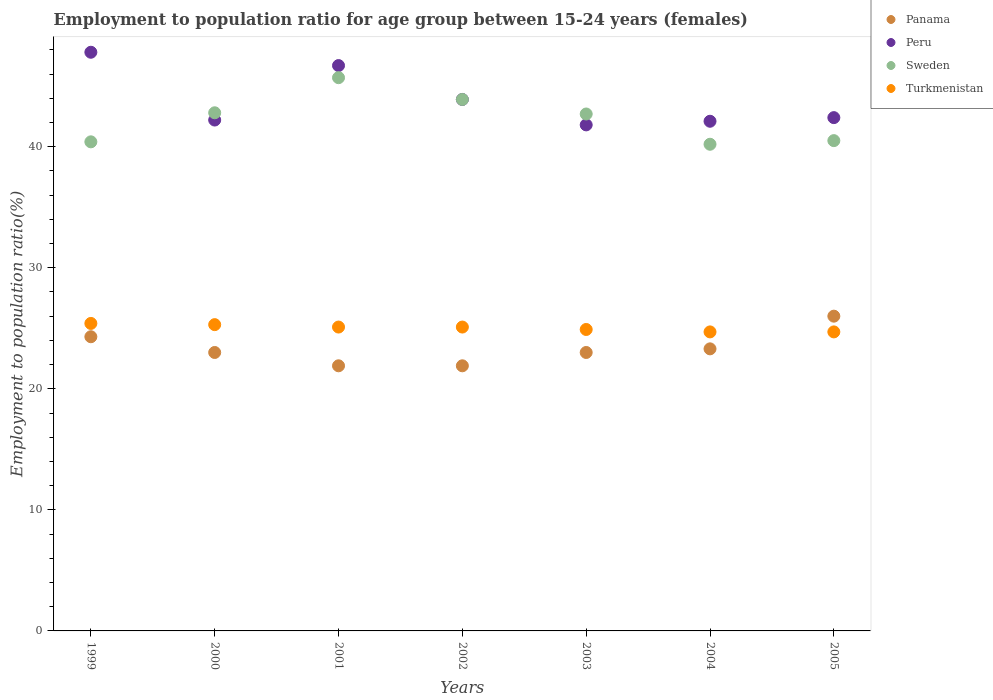What is the employment to population ratio in Peru in 2000?
Give a very brief answer. 42.2. Across all years, what is the maximum employment to population ratio in Turkmenistan?
Provide a succinct answer. 25.4. Across all years, what is the minimum employment to population ratio in Turkmenistan?
Your response must be concise. 24.7. In which year was the employment to population ratio in Turkmenistan minimum?
Offer a terse response. 2004. What is the total employment to population ratio in Peru in the graph?
Your answer should be very brief. 306.9. What is the difference between the employment to population ratio in Turkmenistan in 2001 and that in 2003?
Provide a short and direct response. 0.2. What is the difference between the employment to population ratio in Panama in 2000 and the employment to population ratio in Sweden in 2005?
Make the answer very short. -17.5. What is the average employment to population ratio in Turkmenistan per year?
Offer a very short reply. 25.03. In the year 2000, what is the difference between the employment to population ratio in Peru and employment to population ratio in Panama?
Offer a very short reply. 19.2. What is the ratio of the employment to population ratio in Sweden in 2003 to that in 2005?
Ensure brevity in your answer.  1.05. What is the difference between the highest and the second highest employment to population ratio in Panama?
Your answer should be very brief. 1.7. What is the difference between the highest and the lowest employment to population ratio in Panama?
Keep it short and to the point. 4.1. In how many years, is the employment to population ratio in Sweden greater than the average employment to population ratio in Sweden taken over all years?
Offer a very short reply. 4. Is it the case that in every year, the sum of the employment to population ratio in Turkmenistan and employment to population ratio in Peru  is greater than the sum of employment to population ratio in Sweden and employment to population ratio in Panama?
Make the answer very short. Yes. Is it the case that in every year, the sum of the employment to population ratio in Peru and employment to population ratio in Turkmenistan  is greater than the employment to population ratio in Panama?
Your response must be concise. Yes. Is the employment to population ratio in Panama strictly greater than the employment to population ratio in Sweden over the years?
Your answer should be very brief. No. Is the employment to population ratio in Sweden strictly less than the employment to population ratio in Turkmenistan over the years?
Give a very brief answer. No. How many years are there in the graph?
Keep it short and to the point. 7. Does the graph contain any zero values?
Your answer should be very brief. No. Where does the legend appear in the graph?
Make the answer very short. Top right. How are the legend labels stacked?
Offer a very short reply. Vertical. What is the title of the graph?
Your response must be concise. Employment to population ratio for age group between 15-24 years (females). Does "Peru" appear as one of the legend labels in the graph?
Your response must be concise. Yes. What is the Employment to population ratio(%) of Panama in 1999?
Give a very brief answer. 24.3. What is the Employment to population ratio(%) in Peru in 1999?
Your answer should be very brief. 47.8. What is the Employment to population ratio(%) in Sweden in 1999?
Your response must be concise. 40.4. What is the Employment to population ratio(%) of Turkmenistan in 1999?
Offer a terse response. 25.4. What is the Employment to population ratio(%) of Peru in 2000?
Provide a succinct answer. 42.2. What is the Employment to population ratio(%) of Sweden in 2000?
Your response must be concise. 42.8. What is the Employment to population ratio(%) of Turkmenistan in 2000?
Provide a short and direct response. 25.3. What is the Employment to population ratio(%) of Panama in 2001?
Give a very brief answer. 21.9. What is the Employment to population ratio(%) in Peru in 2001?
Offer a very short reply. 46.7. What is the Employment to population ratio(%) of Sweden in 2001?
Provide a succinct answer. 45.7. What is the Employment to population ratio(%) of Turkmenistan in 2001?
Give a very brief answer. 25.1. What is the Employment to population ratio(%) of Panama in 2002?
Ensure brevity in your answer.  21.9. What is the Employment to population ratio(%) of Peru in 2002?
Make the answer very short. 43.9. What is the Employment to population ratio(%) in Sweden in 2002?
Offer a very short reply. 43.9. What is the Employment to population ratio(%) in Turkmenistan in 2002?
Provide a succinct answer. 25.1. What is the Employment to population ratio(%) in Peru in 2003?
Your response must be concise. 41.8. What is the Employment to population ratio(%) in Sweden in 2003?
Ensure brevity in your answer.  42.7. What is the Employment to population ratio(%) of Turkmenistan in 2003?
Offer a terse response. 24.9. What is the Employment to population ratio(%) of Panama in 2004?
Provide a short and direct response. 23.3. What is the Employment to population ratio(%) in Peru in 2004?
Your answer should be compact. 42.1. What is the Employment to population ratio(%) in Sweden in 2004?
Provide a succinct answer. 40.2. What is the Employment to population ratio(%) in Turkmenistan in 2004?
Make the answer very short. 24.7. What is the Employment to population ratio(%) of Peru in 2005?
Offer a very short reply. 42.4. What is the Employment to population ratio(%) of Sweden in 2005?
Offer a very short reply. 40.5. What is the Employment to population ratio(%) of Turkmenistan in 2005?
Your response must be concise. 24.7. Across all years, what is the maximum Employment to population ratio(%) in Panama?
Your response must be concise. 26. Across all years, what is the maximum Employment to population ratio(%) in Peru?
Your answer should be very brief. 47.8. Across all years, what is the maximum Employment to population ratio(%) of Sweden?
Keep it short and to the point. 45.7. Across all years, what is the maximum Employment to population ratio(%) of Turkmenistan?
Make the answer very short. 25.4. Across all years, what is the minimum Employment to population ratio(%) in Panama?
Your response must be concise. 21.9. Across all years, what is the minimum Employment to population ratio(%) in Peru?
Your answer should be compact. 41.8. Across all years, what is the minimum Employment to population ratio(%) of Sweden?
Ensure brevity in your answer.  40.2. Across all years, what is the minimum Employment to population ratio(%) of Turkmenistan?
Provide a succinct answer. 24.7. What is the total Employment to population ratio(%) of Panama in the graph?
Provide a short and direct response. 163.4. What is the total Employment to population ratio(%) of Peru in the graph?
Your answer should be compact. 306.9. What is the total Employment to population ratio(%) of Sweden in the graph?
Your answer should be very brief. 296.2. What is the total Employment to population ratio(%) of Turkmenistan in the graph?
Your answer should be compact. 175.2. What is the difference between the Employment to population ratio(%) of Sweden in 1999 and that in 2000?
Your answer should be compact. -2.4. What is the difference between the Employment to population ratio(%) of Turkmenistan in 1999 and that in 2000?
Provide a succinct answer. 0.1. What is the difference between the Employment to population ratio(%) of Panama in 1999 and that in 2001?
Ensure brevity in your answer.  2.4. What is the difference between the Employment to population ratio(%) in Sweden in 1999 and that in 2001?
Your response must be concise. -5.3. What is the difference between the Employment to population ratio(%) in Panama in 1999 and that in 2002?
Your answer should be very brief. 2.4. What is the difference between the Employment to population ratio(%) of Peru in 1999 and that in 2002?
Offer a terse response. 3.9. What is the difference between the Employment to population ratio(%) of Turkmenistan in 1999 and that in 2002?
Provide a short and direct response. 0.3. What is the difference between the Employment to population ratio(%) of Panama in 1999 and that in 2003?
Keep it short and to the point. 1.3. What is the difference between the Employment to population ratio(%) in Peru in 1999 and that in 2003?
Your response must be concise. 6. What is the difference between the Employment to population ratio(%) in Sweden in 1999 and that in 2003?
Make the answer very short. -2.3. What is the difference between the Employment to population ratio(%) of Turkmenistan in 1999 and that in 2003?
Your response must be concise. 0.5. What is the difference between the Employment to population ratio(%) of Peru in 1999 and that in 2004?
Provide a succinct answer. 5.7. What is the difference between the Employment to population ratio(%) of Turkmenistan in 1999 and that in 2004?
Provide a short and direct response. 0.7. What is the difference between the Employment to population ratio(%) in Panama in 1999 and that in 2005?
Provide a short and direct response. -1.7. What is the difference between the Employment to population ratio(%) in Sweden in 1999 and that in 2005?
Provide a succinct answer. -0.1. What is the difference between the Employment to population ratio(%) of Peru in 2000 and that in 2001?
Your answer should be compact. -4.5. What is the difference between the Employment to population ratio(%) of Sweden in 2000 and that in 2001?
Provide a succinct answer. -2.9. What is the difference between the Employment to population ratio(%) in Peru in 2000 and that in 2002?
Ensure brevity in your answer.  -1.7. What is the difference between the Employment to population ratio(%) in Peru in 2000 and that in 2003?
Your answer should be compact. 0.4. What is the difference between the Employment to population ratio(%) of Turkmenistan in 2000 and that in 2003?
Keep it short and to the point. 0.4. What is the difference between the Employment to population ratio(%) in Peru in 2000 and that in 2004?
Ensure brevity in your answer.  0.1. What is the difference between the Employment to population ratio(%) in Turkmenistan in 2000 and that in 2004?
Provide a succinct answer. 0.6. What is the difference between the Employment to population ratio(%) in Sweden in 2001 and that in 2002?
Give a very brief answer. 1.8. What is the difference between the Employment to population ratio(%) of Panama in 2001 and that in 2004?
Your response must be concise. -1.4. What is the difference between the Employment to population ratio(%) in Sweden in 2001 and that in 2004?
Provide a succinct answer. 5.5. What is the difference between the Employment to population ratio(%) of Panama in 2001 and that in 2005?
Offer a terse response. -4.1. What is the difference between the Employment to population ratio(%) in Sweden in 2001 and that in 2005?
Your answer should be compact. 5.2. What is the difference between the Employment to population ratio(%) of Panama in 2002 and that in 2003?
Offer a very short reply. -1.1. What is the difference between the Employment to population ratio(%) of Panama in 2002 and that in 2004?
Your response must be concise. -1.4. What is the difference between the Employment to population ratio(%) of Sweden in 2002 and that in 2004?
Give a very brief answer. 3.7. What is the difference between the Employment to population ratio(%) in Turkmenistan in 2002 and that in 2004?
Offer a terse response. 0.4. What is the difference between the Employment to population ratio(%) of Peru in 2002 and that in 2005?
Give a very brief answer. 1.5. What is the difference between the Employment to population ratio(%) in Sweden in 2002 and that in 2005?
Offer a very short reply. 3.4. What is the difference between the Employment to population ratio(%) of Sweden in 2003 and that in 2004?
Your answer should be very brief. 2.5. What is the difference between the Employment to population ratio(%) in Turkmenistan in 2003 and that in 2004?
Ensure brevity in your answer.  0.2. What is the difference between the Employment to population ratio(%) in Panama in 2003 and that in 2005?
Make the answer very short. -3. What is the difference between the Employment to population ratio(%) in Turkmenistan in 2003 and that in 2005?
Provide a short and direct response. 0.2. What is the difference between the Employment to population ratio(%) of Panama in 2004 and that in 2005?
Make the answer very short. -2.7. What is the difference between the Employment to population ratio(%) in Peru in 2004 and that in 2005?
Ensure brevity in your answer.  -0.3. What is the difference between the Employment to population ratio(%) of Turkmenistan in 2004 and that in 2005?
Keep it short and to the point. 0. What is the difference between the Employment to population ratio(%) of Panama in 1999 and the Employment to population ratio(%) of Peru in 2000?
Your answer should be compact. -17.9. What is the difference between the Employment to population ratio(%) in Panama in 1999 and the Employment to population ratio(%) in Sweden in 2000?
Provide a short and direct response. -18.5. What is the difference between the Employment to population ratio(%) of Panama in 1999 and the Employment to population ratio(%) of Turkmenistan in 2000?
Your response must be concise. -1. What is the difference between the Employment to population ratio(%) of Peru in 1999 and the Employment to population ratio(%) of Sweden in 2000?
Offer a very short reply. 5. What is the difference between the Employment to population ratio(%) of Panama in 1999 and the Employment to population ratio(%) of Peru in 2001?
Your answer should be very brief. -22.4. What is the difference between the Employment to population ratio(%) in Panama in 1999 and the Employment to population ratio(%) in Sweden in 2001?
Make the answer very short. -21.4. What is the difference between the Employment to population ratio(%) in Panama in 1999 and the Employment to population ratio(%) in Turkmenistan in 2001?
Provide a short and direct response. -0.8. What is the difference between the Employment to population ratio(%) in Peru in 1999 and the Employment to population ratio(%) in Turkmenistan in 2001?
Your answer should be very brief. 22.7. What is the difference between the Employment to population ratio(%) in Sweden in 1999 and the Employment to population ratio(%) in Turkmenistan in 2001?
Ensure brevity in your answer.  15.3. What is the difference between the Employment to population ratio(%) of Panama in 1999 and the Employment to population ratio(%) of Peru in 2002?
Your answer should be very brief. -19.6. What is the difference between the Employment to population ratio(%) in Panama in 1999 and the Employment to population ratio(%) in Sweden in 2002?
Keep it short and to the point. -19.6. What is the difference between the Employment to population ratio(%) of Peru in 1999 and the Employment to population ratio(%) of Sweden in 2002?
Keep it short and to the point. 3.9. What is the difference between the Employment to population ratio(%) in Peru in 1999 and the Employment to population ratio(%) in Turkmenistan in 2002?
Ensure brevity in your answer.  22.7. What is the difference between the Employment to population ratio(%) of Panama in 1999 and the Employment to population ratio(%) of Peru in 2003?
Ensure brevity in your answer.  -17.5. What is the difference between the Employment to population ratio(%) of Panama in 1999 and the Employment to population ratio(%) of Sweden in 2003?
Ensure brevity in your answer.  -18.4. What is the difference between the Employment to population ratio(%) in Panama in 1999 and the Employment to population ratio(%) in Turkmenistan in 2003?
Offer a very short reply. -0.6. What is the difference between the Employment to population ratio(%) in Peru in 1999 and the Employment to population ratio(%) in Sweden in 2003?
Your answer should be very brief. 5.1. What is the difference between the Employment to population ratio(%) in Peru in 1999 and the Employment to population ratio(%) in Turkmenistan in 2003?
Offer a very short reply. 22.9. What is the difference between the Employment to population ratio(%) of Panama in 1999 and the Employment to population ratio(%) of Peru in 2004?
Offer a terse response. -17.8. What is the difference between the Employment to population ratio(%) of Panama in 1999 and the Employment to population ratio(%) of Sweden in 2004?
Offer a terse response. -15.9. What is the difference between the Employment to population ratio(%) of Peru in 1999 and the Employment to population ratio(%) of Turkmenistan in 2004?
Your answer should be compact. 23.1. What is the difference between the Employment to population ratio(%) of Sweden in 1999 and the Employment to population ratio(%) of Turkmenistan in 2004?
Offer a terse response. 15.7. What is the difference between the Employment to population ratio(%) of Panama in 1999 and the Employment to population ratio(%) of Peru in 2005?
Keep it short and to the point. -18.1. What is the difference between the Employment to population ratio(%) of Panama in 1999 and the Employment to population ratio(%) of Sweden in 2005?
Provide a succinct answer. -16.2. What is the difference between the Employment to population ratio(%) in Panama in 1999 and the Employment to population ratio(%) in Turkmenistan in 2005?
Make the answer very short. -0.4. What is the difference between the Employment to population ratio(%) of Peru in 1999 and the Employment to population ratio(%) of Turkmenistan in 2005?
Provide a succinct answer. 23.1. What is the difference between the Employment to population ratio(%) in Panama in 2000 and the Employment to population ratio(%) in Peru in 2001?
Offer a very short reply. -23.7. What is the difference between the Employment to population ratio(%) in Panama in 2000 and the Employment to population ratio(%) in Sweden in 2001?
Your response must be concise. -22.7. What is the difference between the Employment to population ratio(%) in Panama in 2000 and the Employment to population ratio(%) in Turkmenistan in 2001?
Make the answer very short. -2.1. What is the difference between the Employment to population ratio(%) of Panama in 2000 and the Employment to population ratio(%) of Peru in 2002?
Provide a succinct answer. -20.9. What is the difference between the Employment to population ratio(%) of Panama in 2000 and the Employment to population ratio(%) of Sweden in 2002?
Keep it short and to the point. -20.9. What is the difference between the Employment to population ratio(%) of Peru in 2000 and the Employment to population ratio(%) of Sweden in 2002?
Offer a very short reply. -1.7. What is the difference between the Employment to population ratio(%) in Sweden in 2000 and the Employment to population ratio(%) in Turkmenistan in 2002?
Your answer should be compact. 17.7. What is the difference between the Employment to population ratio(%) in Panama in 2000 and the Employment to population ratio(%) in Peru in 2003?
Ensure brevity in your answer.  -18.8. What is the difference between the Employment to population ratio(%) of Panama in 2000 and the Employment to population ratio(%) of Sweden in 2003?
Offer a very short reply. -19.7. What is the difference between the Employment to population ratio(%) of Sweden in 2000 and the Employment to population ratio(%) of Turkmenistan in 2003?
Give a very brief answer. 17.9. What is the difference between the Employment to population ratio(%) of Panama in 2000 and the Employment to population ratio(%) of Peru in 2004?
Ensure brevity in your answer.  -19.1. What is the difference between the Employment to population ratio(%) of Panama in 2000 and the Employment to population ratio(%) of Sweden in 2004?
Keep it short and to the point. -17.2. What is the difference between the Employment to population ratio(%) of Panama in 2000 and the Employment to population ratio(%) of Turkmenistan in 2004?
Make the answer very short. -1.7. What is the difference between the Employment to population ratio(%) in Sweden in 2000 and the Employment to population ratio(%) in Turkmenistan in 2004?
Your answer should be very brief. 18.1. What is the difference between the Employment to population ratio(%) in Panama in 2000 and the Employment to population ratio(%) in Peru in 2005?
Give a very brief answer. -19.4. What is the difference between the Employment to population ratio(%) in Panama in 2000 and the Employment to population ratio(%) in Sweden in 2005?
Give a very brief answer. -17.5. What is the difference between the Employment to population ratio(%) in Peru in 2000 and the Employment to population ratio(%) in Turkmenistan in 2005?
Provide a succinct answer. 17.5. What is the difference between the Employment to population ratio(%) of Sweden in 2000 and the Employment to population ratio(%) of Turkmenistan in 2005?
Offer a terse response. 18.1. What is the difference between the Employment to population ratio(%) in Panama in 2001 and the Employment to population ratio(%) in Peru in 2002?
Offer a terse response. -22. What is the difference between the Employment to population ratio(%) of Panama in 2001 and the Employment to population ratio(%) of Sweden in 2002?
Keep it short and to the point. -22. What is the difference between the Employment to population ratio(%) in Panama in 2001 and the Employment to population ratio(%) in Turkmenistan in 2002?
Make the answer very short. -3.2. What is the difference between the Employment to population ratio(%) in Peru in 2001 and the Employment to population ratio(%) in Turkmenistan in 2002?
Your response must be concise. 21.6. What is the difference between the Employment to population ratio(%) in Sweden in 2001 and the Employment to population ratio(%) in Turkmenistan in 2002?
Your answer should be compact. 20.6. What is the difference between the Employment to population ratio(%) of Panama in 2001 and the Employment to population ratio(%) of Peru in 2003?
Provide a short and direct response. -19.9. What is the difference between the Employment to population ratio(%) in Panama in 2001 and the Employment to population ratio(%) in Sweden in 2003?
Provide a succinct answer. -20.8. What is the difference between the Employment to population ratio(%) of Panama in 2001 and the Employment to population ratio(%) of Turkmenistan in 2003?
Your answer should be compact. -3. What is the difference between the Employment to population ratio(%) in Peru in 2001 and the Employment to population ratio(%) in Sweden in 2003?
Offer a very short reply. 4. What is the difference between the Employment to population ratio(%) of Peru in 2001 and the Employment to population ratio(%) of Turkmenistan in 2003?
Your answer should be compact. 21.8. What is the difference between the Employment to population ratio(%) of Sweden in 2001 and the Employment to population ratio(%) of Turkmenistan in 2003?
Make the answer very short. 20.8. What is the difference between the Employment to population ratio(%) in Panama in 2001 and the Employment to population ratio(%) in Peru in 2004?
Your answer should be compact. -20.2. What is the difference between the Employment to population ratio(%) in Panama in 2001 and the Employment to population ratio(%) in Sweden in 2004?
Make the answer very short. -18.3. What is the difference between the Employment to population ratio(%) of Panama in 2001 and the Employment to population ratio(%) of Turkmenistan in 2004?
Offer a terse response. -2.8. What is the difference between the Employment to population ratio(%) in Peru in 2001 and the Employment to population ratio(%) in Sweden in 2004?
Ensure brevity in your answer.  6.5. What is the difference between the Employment to population ratio(%) of Sweden in 2001 and the Employment to population ratio(%) of Turkmenistan in 2004?
Offer a terse response. 21. What is the difference between the Employment to population ratio(%) in Panama in 2001 and the Employment to population ratio(%) in Peru in 2005?
Provide a succinct answer. -20.5. What is the difference between the Employment to population ratio(%) in Panama in 2001 and the Employment to population ratio(%) in Sweden in 2005?
Make the answer very short. -18.6. What is the difference between the Employment to population ratio(%) in Panama in 2001 and the Employment to population ratio(%) in Turkmenistan in 2005?
Offer a terse response. -2.8. What is the difference between the Employment to population ratio(%) of Peru in 2001 and the Employment to population ratio(%) of Turkmenistan in 2005?
Provide a short and direct response. 22. What is the difference between the Employment to population ratio(%) in Panama in 2002 and the Employment to population ratio(%) in Peru in 2003?
Give a very brief answer. -19.9. What is the difference between the Employment to population ratio(%) of Panama in 2002 and the Employment to population ratio(%) of Sweden in 2003?
Give a very brief answer. -20.8. What is the difference between the Employment to population ratio(%) of Panama in 2002 and the Employment to population ratio(%) of Turkmenistan in 2003?
Your response must be concise. -3. What is the difference between the Employment to population ratio(%) in Sweden in 2002 and the Employment to population ratio(%) in Turkmenistan in 2003?
Ensure brevity in your answer.  19. What is the difference between the Employment to population ratio(%) of Panama in 2002 and the Employment to population ratio(%) of Peru in 2004?
Provide a short and direct response. -20.2. What is the difference between the Employment to population ratio(%) in Panama in 2002 and the Employment to population ratio(%) in Sweden in 2004?
Keep it short and to the point. -18.3. What is the difference between the Employment to population ratio(%) in Panama in 2002 and the Employment to population ratio(%) in Turkmenistan in 2004?
Ensure brevity in your answer.  -2.8. What is the difference between the Employment to population ratio(%) of Peru in 2002 and the Employment to population ratio(%) of Sweden in 2004?
Your answer should be very brief. 3.7. What is the difference between the Employment to population ratio(%) in Peru in 2002 and the Employment to population ratio(%) in Turkmenistan in 2004?
Provide a succinct answer. 19.2. What is the difference between the Employment to population ratio(%) in Panama in 2002 and the Employment to population ratio(%) in Peru in 2005?
Provide a short and direct response. -20.5. What is the difference between the Employment to population ratio(%) of Panama in 2002 and the Employment to population ratio(%) of Sweden in 2005?
Keep it short and to the point. -18.6. What is the difference between the Employment to population ratio(%) of Peru in 2002 and the Employment to population ratio(%) of Turkmenistan in 2005?
Provide a succinct answer. 19.2. What is the difference between the Employment to population ratio(%) of Sweden in 2002 and the Employment to population ratio(%) of Turkmenistan in 2005?
Provide a short and direct response. 19.2. What is the difference between the Employment to population ratio(%) of Panama in 2003 and the Employment to population ratio(%) of Peru in 2004?
Ensure brevity in your answer.  -19.1. What is the difference between the Employment to population ratio(%) in Panama in 2003 and the Employment to population ratio(%) in Sweden in 2004?
Offer a terse response. -17.2. What is the difference between the Employment to population ratio(%) of Peru in 2003 and the Employment to population ratio(%) of Sweden in 2004?
Your response must be concise. 1.6. What is the difference between the Employment to population ratio(%) of Panama in 2003 and the Employment to population ratio(%) of Peru in 2005?
Provide a short and direct response. -19.4. What is the difference between the Employment to population ratio(%) of Panama in 2003 and the Employment to population ratio(%) of Sweden in 2005?
Ensure brevity in your answer.  -17.5. What is the difference between the Employment to population ratio(%) in Panama in 2003 and the Employment to population ratio(%) in Turkmenistan in 2005?
Your answer should be very brief. -1.7. What is the difference between the Employment to population ratio(%) of Peru in 2003 and the Employment to population ratio(%) of Turkmenistan in 2005?
Keep it short and to the point. 17.1. What is the difference between the Employment to population ratio(%) in Panama in 2004 and the Employment to population ratio(%) in Peru in 2005?
Give a very brief answer. -19.1. What is the difference between the Employment to population ratio(%) in Panama in 2004 and the Employment to population ratio(%) in Sweden in 2005?
Give a very brief answer. -17.2. What is the difference between the Employment to population ratio(%) of Sweden in 2004 and the Employment to population ratio(%) of Turkmenistan in 2005?
Ensure brevity in your answer.  15.5. What is the average Employment to population ratio(%) of Panama per year?
Make the answer very short. 23.34. What is the average Employment to population ratio(%) in Peru per year?
Keep it short and to the point. 43.84. What is the average Employment to population ratio(%) of Sweden per year?
Offer a terse response. 42.31. What is the average Employment to population ratio(%) of Turkmenistan per year?
Offer a terse response. 25.03. In the year 1999, what is the difference between the Employment to population ratio(%) in Panama and Employment to population ratio(%) in Peru?
Offer a very short reply. -23.5. In the year 1999, what is the difference between the Employment to population ratio(%) of Panama and Employment to population ratio(%) of Sweden?
Make the answer very short. -16.1. In the year 1999, what is the difference between the Employment to population ratio(%) in Peru and Employment to population ratio(%) in Sweden?
Provide a short and direct response. 7.4. In the year 1999, what is the difference between the Employment to population ratio(%) of Peru and Employment to population ratio(%) of Turkmenistan?
Offer a very short reply. 22.4. In the year 2000, what is the difference between the Employment to population ratio(%) of Panama and Employment to population ratio(%) of Peru?
Make the answer very short. -19.2. In the year 2000, what is the difference between the Employment to population ratio(%) in Panama and Employment to population ratio(%) in Sweden?
Keep it short and to the point. -19.8. In the year 2000, what is the difference between the Employment to population ratio(%) in Panama and Employment to population ratio(%) in Turkmenistan?
Offer a terse response. -2.3. In the year 2000, what is the difference between the Employment to population ratio(%) in Peru and Employment to population ratio(%) in Sweden?
Provide a short and direct response. -0.6. In the year 2000, what is the difference between the Employment to population ratio(%) in Peru and Employment to population ratio(%) in Turkmenistan?
Give a very brief answer. 16.9. In the year 2000, what is the difference between the Employment to population ratio(%) of Sweden and Employment to population ratio(%) of Turkmenistan?
Your answer should be very brief. 17.5. In the year 2001, what is the difference between the Employment to population ratio(%) of Panama and Employment to population ratio(%) of Peru?
Keep it short and to the point. -24.8. In the year 2001, what is the difference between the Employment to population ratio(%) in Panama and Employment to population ratio(%) in Sweden?
Your response must be concise. -23.8. In the year 2001, what is the difference between the Employment to population ratio(%) in Panama and Employment to population ratio(%) in Turkmenistan?
Give a very brief answer. -3.2. In the year 2001, what is the difference between the Employment to population ratio(%) of Peru and Employment to population ratio(%) of Sweden?
Provide a short and direct response. 1. In the year 2001, what is the difference between the Employment to population ratio(%) in Peru and Employment to population ratio(%) in Turkmenistan?
Offer a very short reply. 21.6. In the year 2001, what is the difference between the Employment to population ratio(%) in Sweden and Employment to population ratio(%) in Turkmenistan?
Provide a short and direct response. 20.6. In the year 2002, what is the difference between the Employment to population ratio(%) of Panama and Employment to population ratio(%) of Sweden?
Give a very brief answer. -22. In the year 2002, what is the difference between the Employment to population ratio(%) of Peru and Employment to population ratio(%) of Sweden?
Make the answer very short. 0. In the year 2002, what is the difference between the Employment to population ratio(%) in Peru and Employment to population ratio(%) in Turkmenistan?
Give a very brief answer. 18.8. In the year 2002, what is the difference between the Employment to population ratio(%) in Sweden and Employment to population ratio(%) in Turkmenistan?
Provide a succinct answer. 18.8. In the year 2003, what is the difference between the Employment to population ratio(%) in Panama and Employment to population ratio(%) in Peru?
Provide a short and direct response. -18.8. In the year 2003, what is the difference between the Employment to population ratio(%) in Panama and Employment to population ratio(%) in Sweden?
Provide a succinct answer. -19.7. In the year 2003, what is the difference between the Employment to population ratio(%) in Peru and Employment to population ratio(%) in Sweden?
Your answer should be compact. -0.9. In the year 2003, what is the difference between the Employment to population ratio(%) in Sweden and Employment to population ratio(%) in Turkmenistan?
Give a very brief answer. 17.8. In the year 2004, what is the difference between the Employment to population ratio(%) in Panama and Employment to population ratio(%) in Peru?
Your response must be concise. -18.8. In the year 2004, what is the difference between the Employment to population ratio(%) in Panama and Employment to population ratio(%) in Sweden?
Your answer should be very brief. -16.9. In the year 2004, what is the difference between the Employment to population ratio(%) of Peru and Employment to population ratio(%) of Sweden?
Your answer should be compact. 1.9. In the year 2004, what is the difference between the Employment to population ratio(%) of Peru and Employment to population ratio(%) of Turkmenistan?
Make the answer very short. 17.4. In the year 2005, what is the difference between the Employment to population ratio(%) in Panama and Employment to population ratio(%) in Peru?
Make the answer very short. -16.4. In the year 2005, what is the difference between the Employment to population ratio(%) in Panama and Employment to population ratio(%) in Sweden?
Keep it short and to the point. -14.5. In the year 2005, what is the difference between the Employment to population ratio(%) in Panama and Employment to population ratio(%) in Turkmenistan?
Give a very brief answer. 1.3. In the year 2005, what is the difference between the Employment to population ratio(%) of Peru and Employment to population ratio(%) of Sweden?
Give a very brief answer. 1.9. In the year 2005, what is the difference between the Employment to population ratio(%) in Sweden and Employment to population ratio(%) in Turkmenistan?
Ensure brevity in your answer.  15.8. What is the ratio of the Employment to population ratio(%) in Panama in 1999 to that in 2000?
Ensure brevity in your answer.  1.06. What is the ratio of the Employment to population ratio(%) in Peru in 1999 to that in 2000?
Offer a terse response. 1.13. What is the ratio of the Employment to population ratio(%) of Sweden in 1999 to that in 2000?
Your answer should be compact. 0.94. What is the ratio of the Employment to population ratio(%) of Turkmenistan in 1999 to that in 2000?
Give a very brief answer. 1. What is the ratio of the Employment to population ratio(%) in Panama in 1999 to that in 2001?
Offer a terse response. 1.11. What is the ratio of the Employment to population ratio(%) of Peru in 1999 to that in 2001?
Your response must be concise. 1.02. What is the ratio of the Employment to population ratio(%) of Sweden in 1999 to that in 2001?
Your answer should be compact. 0.88. What is the ratio of the Employment to population ratio(%) of Turkmenistan in 1999 to that in 2001?
Offer a terse response. 1.01. What is the ratio of the Employment to population ratio(%) of Panama in 1999 to that in 2002?
Offer a very short reply. 1.11. What is the ratio of the Employment to population ratio(%) of Peru in 1999 to that in 2002?
Your answer should be compact. 1.09. What is the ratio of the Employment to population ratio(%) of Sweden in 1999 to that in 2002?
Provide a succinct answer. 0.92. What is the ratio of the Employment to population ratio(%) in Panama in 1999 to that in 2003?
Ensure brevity in your answer.  1.06. What is the ratio of the Employment to population ratio(%) of Peru in 1999 to that in 2003?
Provide a succinct answer. 1.14. What is the ratio of the Employment to population ratio(%) of Sweden in 1999 to that in 2003?
Provide a succinct answer. 0.95. What is the ratio of the Employment to population ratio(%) in Turkmenistan in 1999 to that in 2003?
Offer a terse response. 1.02. What is the ratio of the Employment to population ratio(%) of Panama in 1999 to that in 2004?
Provide a succinct answer. 1.04. What is the ratio of the Employment to population ratio(%) in Peru in 1999 to that in 2004?
Offer a terse response. 1.14. What is the ratio of the Employment to population ratio(%) of Turkmenistan in 1999 to that in 2004?
Make the answer very short. 1.03. What is the ratio of the Employment to population ratio(%) in Panama in 1999 to that in 2005?
Ensure brevity in your answer.  0.93. What is the ratio of the Employment to population ratio(%) of Peru in 1999 to that in 2005?
Offer a terse response. 1.13. What is the ratio of the Employment to population ratio(%) of Sweden in 1999 to that in 2005?
Your answer should be compact. 1. What is the ratio of the Employment to population ratio(%) in Turkmenistan in 1999 to that in 2005?
Provide a succinct answer. 1.03. What is the ratio of the Employment to population ratio(%) of Panama in 2000 to that in 2001?
Offer a terse response. 1.05. What is the ratio of the Employment to population ratio(%) in Peru in 2000 to that in 2001?
Ensure brevity in your answer.  0.9. What is the ratio of the Employment to population ratio(%) in Sweden in 2000 to that in 2001?
Make the answer very short. 0.94. What is the ratio of the Employment to population ratio(%) of Turkmenistan in 2000 to that in 2001?
Offer a terse response. 1.01. What is the ratio of the Employment to population ratio(%) of Panama in 2000 to that in 2002?
Offer a terse response. 1.05. What is the ratio of the Employment to population ratio(%) in Peru in 2000 to that in 2002?
Ensure brevity in your answer.  0.96. What is the ratio of the Employment to population ratio(%) of Sweden in 2000 to that in 2002?
Make the answer very short. 0.97. What is the ratio of the Employment to population ratio(%) of Peru in 2000 to that in 2003?
Ensure brevity in your answer.  1.01. What is the ratio of the Employment to population ratio(%) of Turkmenistan in 2000 to that in 2003?
Your response must be concise. 1.02. What is the ratio of the Employment to population ratio(%) in Panama in 2000 to that in 2004?
Your answer should be compact. 0.99. What is the ratio of the Employment to population ratio(%) of Peru in 2000 to that in 2004?
Offer a terse response. 1. What is the ratio of the Employment to population ratio(%) in Sweden in 2000 to that in 2004?
Keep it short and to the point. 1.06. What is the ratio of the Employment to population ratio(%) of Turkmenistan in 2000 to that in 2004?
Provide a short and direct response. 1.02. What is the ratio of the Employment to population ratio(%) of Panama in 2000 to that in 2005?
Make the answer very short. 0.88. What is the ratio of the Employment to population ratio(%) in Peru in 2000 to that in 2005?
Your response must be concise. 1. What is the ratio of the Employment to population ratio(%) in Sweden in 2000 to that in 2005?
Give a very brief answer. 1.06. What is the ratio of the Employment to population ratio(%) of Turkmenistan in 2000 to that in 2005?
Offer a terse response. 1.02. What is the ratio of the Employment to population ratio(%) of Peru in 2001 to that in 2002?
Provide a succinct answer. 1.06. What is the ratio of the Employment to population ratio(%) in Sweden in 2001 to that in 2002?
Offer a terse response. 1.04. What is the ratio of the Employment to population ratio(%) in Turkmenistan in 2001 to that in 2002?
Ensure brevity in your answer.  1. What is the ratio of the Employment to population ratio(%) in Panama in 2001 to that in 2003?
Offer a terse response. 0.95. What is the ratio of the Employment to population ratio(%) of Peru in 2001 to that in 2003?
Offer a terse response. 1.12. What is the ratio of the Employment to population ratio(%) in Sweden in 2001 to that in 2003?
Ensure brevity in your answer.  1.07. What is the ratio of the Employment to population ratio(%) in Turkmenistan in 2001 to that in 2003?
Make the answer very short. 1.01. What is the ratio of the Employment to population ratio(%) of Panama in 2001 to that in 2004?
Offer a terse response. 0.94. What is the ratio of the Employment to population ratio(%) of Peru in 2001 to that in 2004?
Provide a succinct answer. 1.11. What is the ratio of the Employment to population ratio(%) of Sweden in 2001 to that in 2004?
Give a very brief answer. 1.14. What is the ratio of the Employment to population ratio(%) of Turkmenistan in 2001 to that in 2004?
Offer a very short reply. 1.02. What is the ratio of the Employment to population ratio(%) in Panama in 2001 to that in 2005?
Offer a very short reply. 0.84. What is the ratio of the Employment to population ratio(%) in Peru in 2001 to that in 2005?
Offer a terse response. 1.1. What is the ratio of the Employment to population ratio(%) in Sweden in 2001 to that in 2005?
Your answer should be very brief. 1.13. What is the ratio of the Employment to population ratio(%) of Turkmenistan in 2001 to that in 2005?
Your response must be concise. 1.02. What is the ratio of the Employment to population ratio(%) of Panama in 2002 to that in 2003?
Keep it short and to the point. 0.95. What is the ratio of the Employment to population ratio(%) of Peru in 2002 to that in 2003?
Make the answer very short. 1.05. What is the ratio of the Employment to population ratio(%) in Sweden in 2002 to that in 2003?
Provide a succinct answer. 1.03. What is the ratio of the Employment to population ratio(%) of Panama in 2002 to that in 2004?
Provide a short and direct response. 0.94. What is the ratio of the Employment to population ratio(%) of Peru in 2002 to that in 2004?
Ensure brevity in your answer.  1.04. What is the ratio of the Employment to population ratio(%) in Sweden in 2002 to that in 2004?
Your response must be concise. 1.09. What is the ratio of the Employment to population ratio(%) in Turkmenistan in 2002 to that in 2004?
Provide a short and direct response. 1.02. What is the ratio of the Employment to population ratio(%) in Panama in 2002 to that in 2005?
Ensure brevity in your answer.  0.84. What is the ratio of the Employment to population ratio(%) in Peru in 2002 to that in 2005?
Provide a short and direct response. 1.04. What is the ratio of the Employment to population ratio(%) in Sweden in 2002 to that in 2005?
Your answer should be very brief. 1.08. What is the ratio of the Employment to population ratio(%) in Turkmenistan in 2002 to that in 2005?
Your answer should be compact. 1.02. What is the ratio of the Employment to population ratio(%) of Panama in 2003 to that in 2004?
Offer a terse response. 0.99. What is the ratio of the Employment to population ratio(%) of Sweden in 2003 to that in 2004?
Provide a short and direct response. 1.06. What is the ratio of the Employment to population ratio(%) of Panama in 2003 to that in 2005?
Give a very brief answer. 0.88. What is the ratio of the Employment to population ratio(%) in Peru in 2003 to that in 2005?
Provide a succinct answer. 0.99. What is the ratio of the Employment to population ratio(%) of Sweden in 2003 to that in 2005?
Keep it short and to the point. 1.05. What is the ratio of the Employment to population ratio(%) of Turkmenistan in 2003 to that in 2005?
Offer a terse response. 1.01. What is the ratio of the Employment to population ratio(%) in Panama in 2004 to that in 2005?
Offer a terse response. 0.9. What is the ratio of the Employment to population ratio(%) of Peru in 2004 to that in 2005?
Make the answer very short. 0.99. What is the ratio of the Employment to population ratio(%) of Turkmenistan in 2004 to that in 2005?
Give a very brief answer. 1. What is the difference between the highest and the second highest Employment to population ratio(%) of Peru?
Give a very brief answer. 1.1. What is the difference between the highest and the second highest Employment to population ratio(%) of Sweden?
Your answer should be very brief. 1.8. What is the difference between the highest and the lowest Employment to population ratio(%) of Panama?
Ensure brevity in your answer.  4.1. What is the difference between the highest and the lowest Employment to population ratio(%) of Peru?
Keep it short and to the point. 6. What is the difference between the highest and the lowest Employment to population ratio(%) of Sweden?
Your answer should be compact. 5.5. What is the difference between the highest and the lowest Employment to population ratio(%) in Turkmenistan?
Provide a short and direct response. 0.7. 